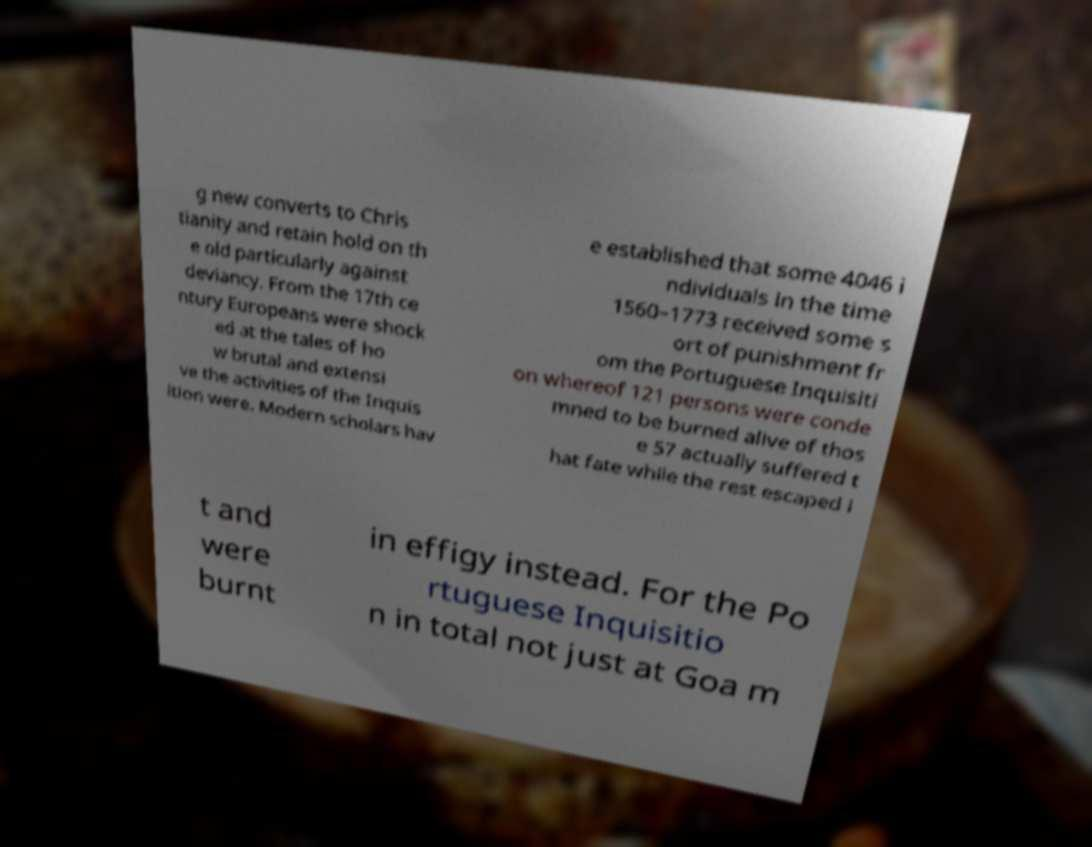There's text embedded in this image that I need extracted. Can you transcribe it verbatim? g new converts to Chris tianity and retain hold on th e old particularly against deviancy. From the 17th ce ntury Europeans were shock ed at the tales of ho w brutal and extensi ve the activities of the Inquis ition were. Modern scholars hav e established that some 4046 i ndividuals in the time 1560–1773 received some s ort of punishment fr om the Portuguese Inquisiti on whereof 121 persons were conde mned to be burned alive of thos e 57 actually suffered t hat fate while the rest escaped i t and were burnt in effigy instead. For the Po rtuguese Inquisitio n in total not just at Goa m 